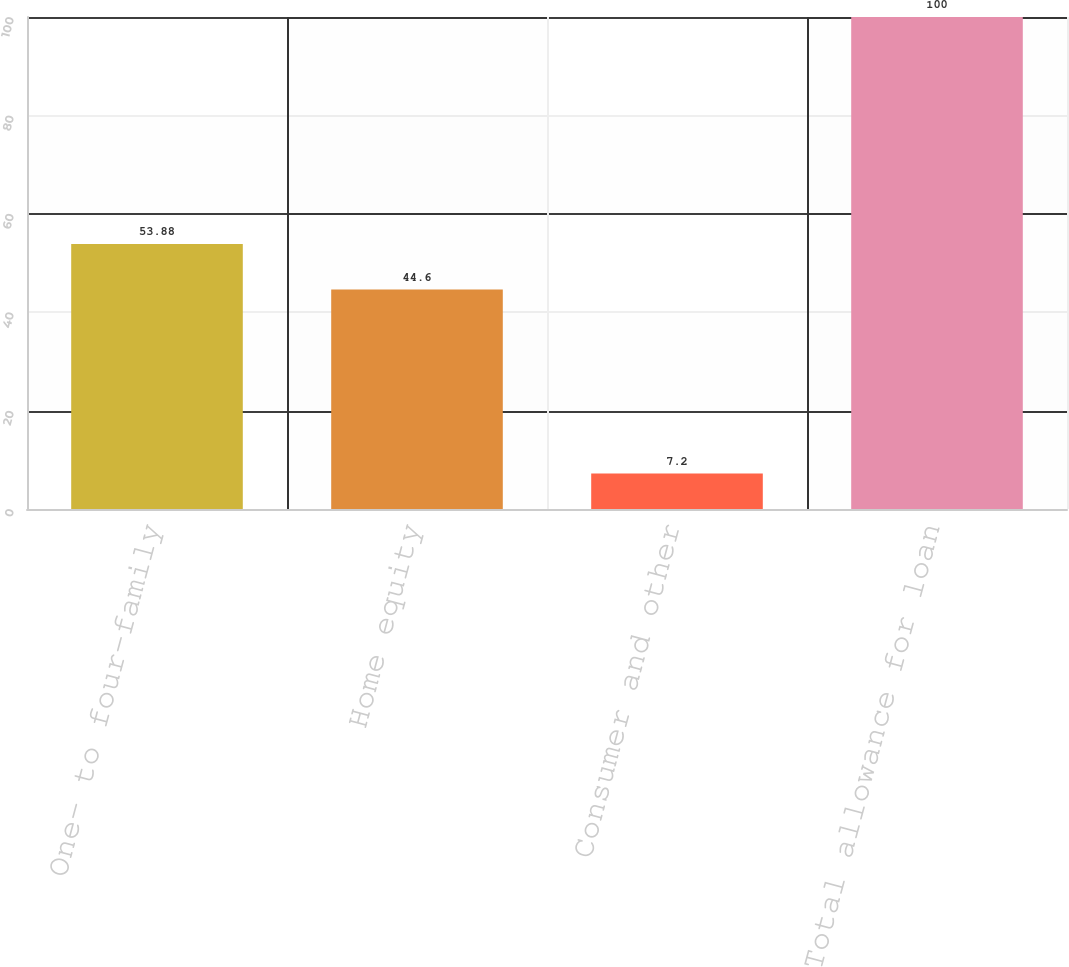Convert chart to OTSL. <chart><loc_0><loc_0><loc_500><loc_500><bar_chart><fcel>One- to four-family<fcel>Home equity<fcel>Consumer and other<fcel>Total allowance for loan<nl><fcel>53.88<fcel>44.6<fcel>7.2<fcel>100<nl></chart> 